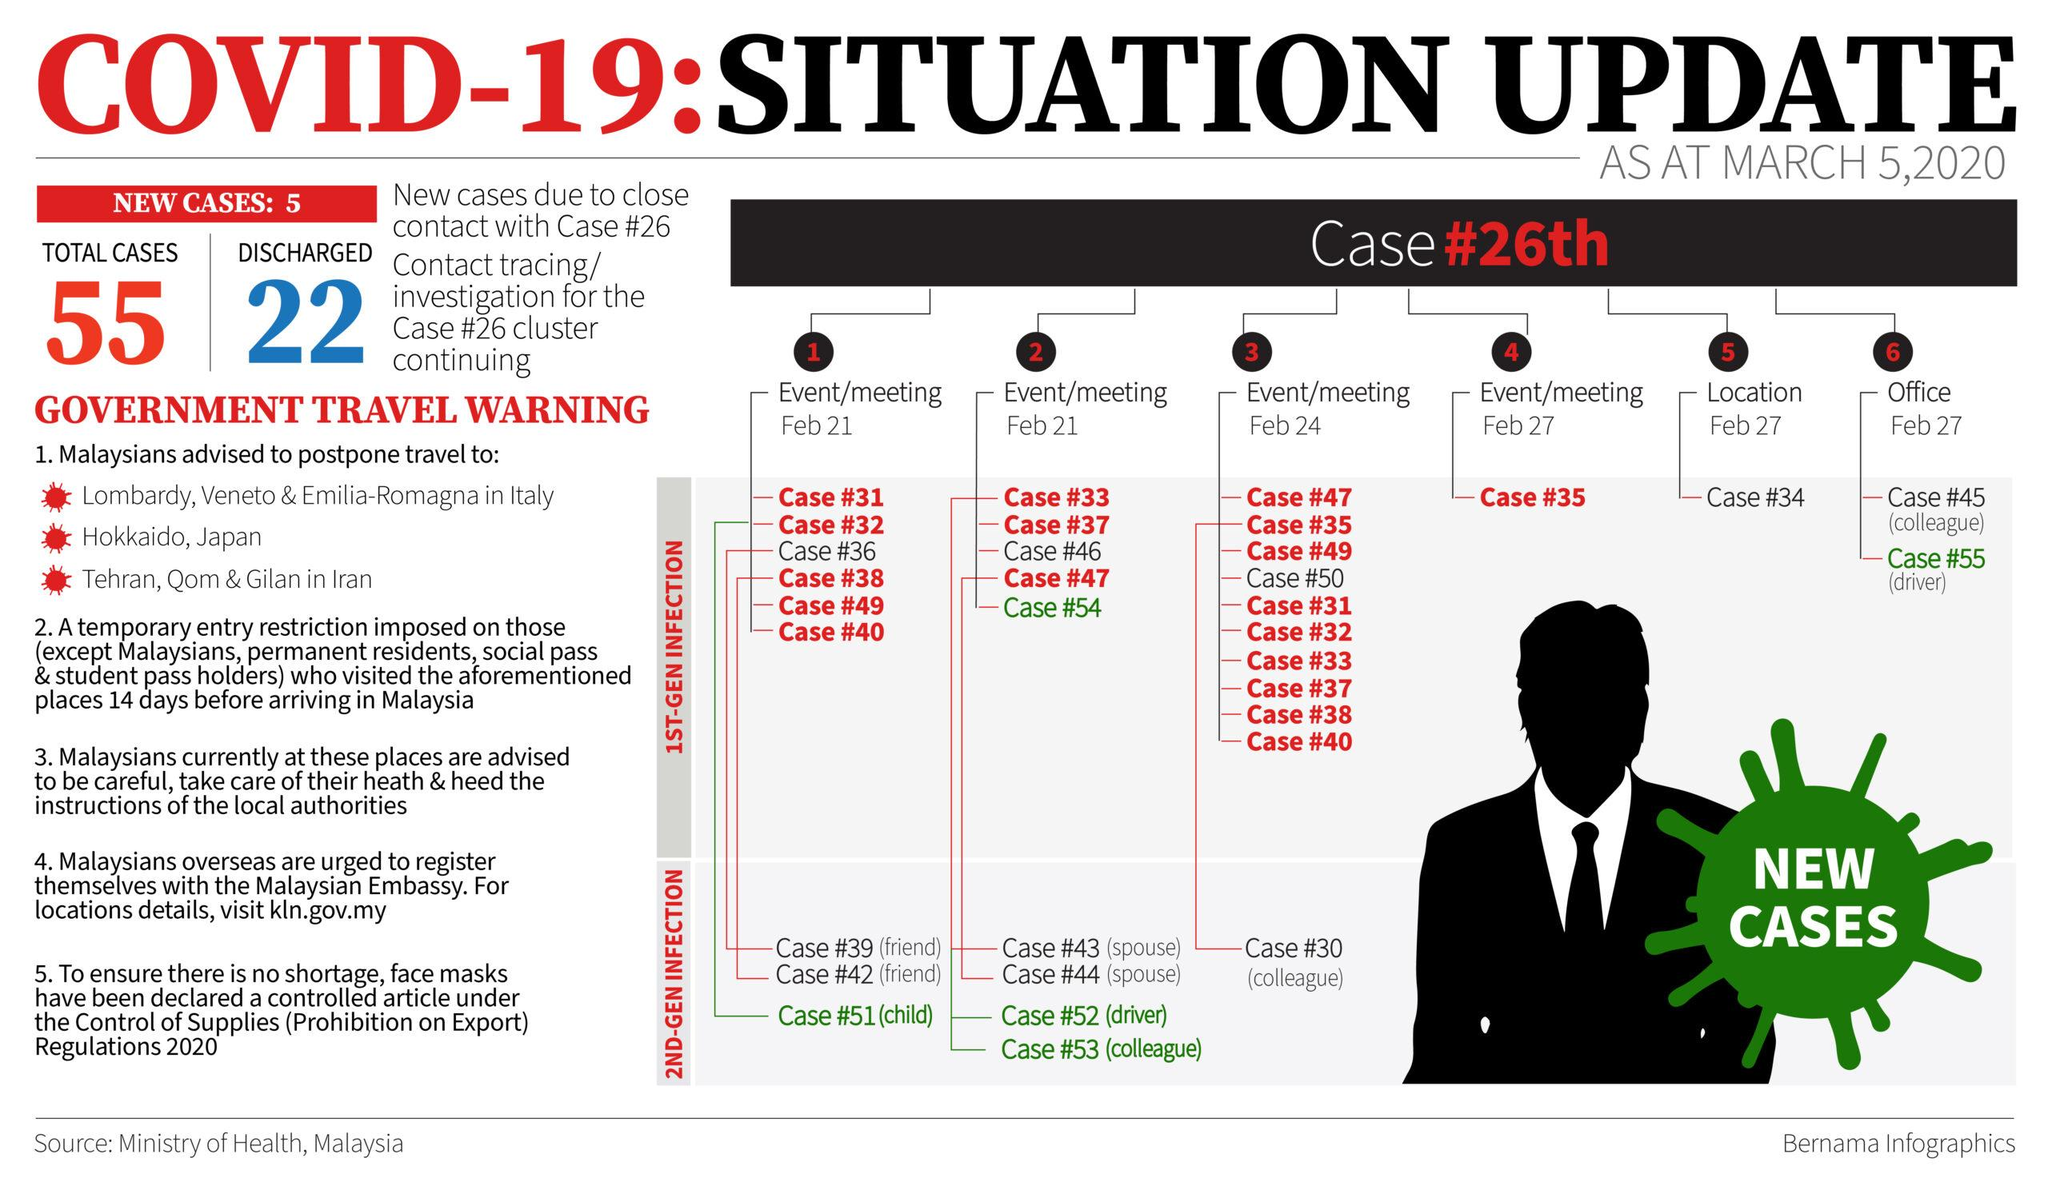Draw attention to some important aspects in this diagram. Out of the total cases, 33 remain active. 